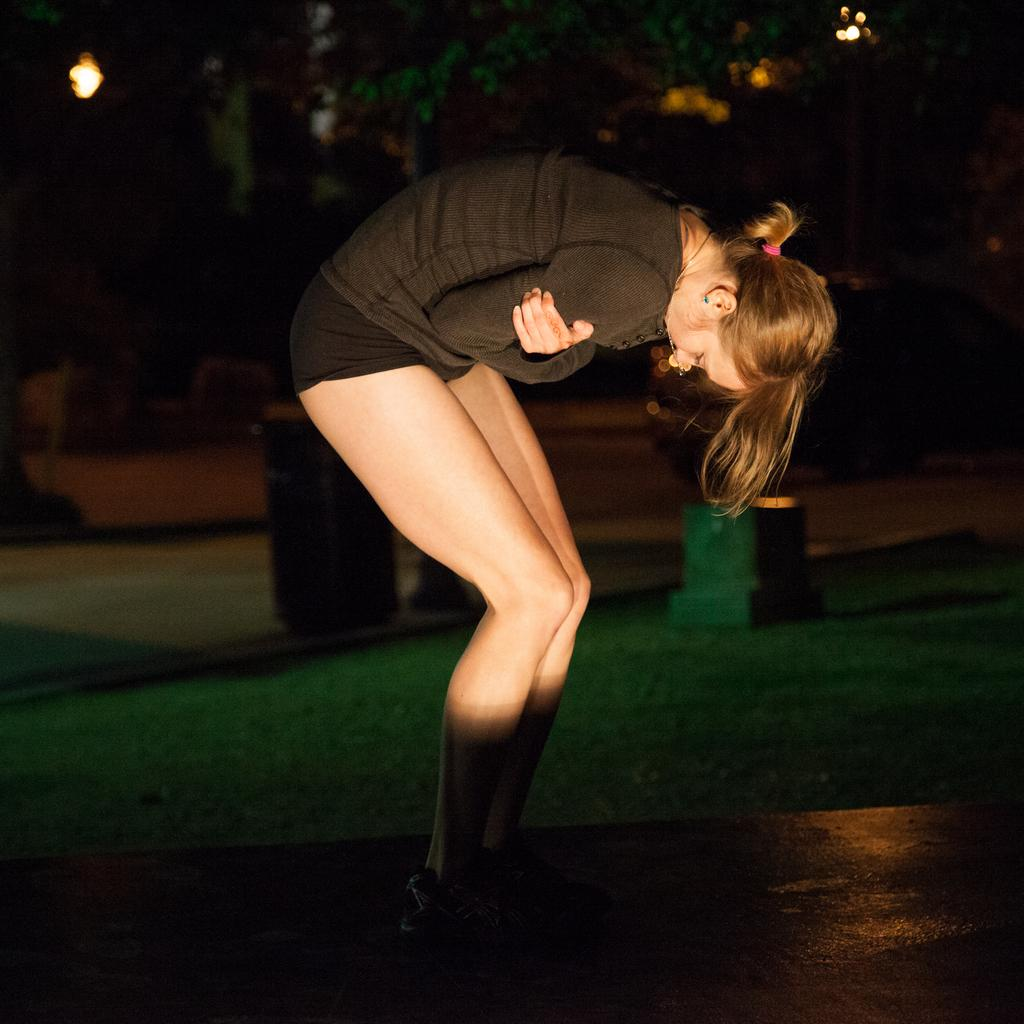Who is present in the image? There is a woman in the image. What is the woman's position in relation to the land? The woman is standing on the land. What color is the dress the woman is wearing? The woman is wearing a brown dress. What can be seen in the background of the image? There are trees in the background of the image. What type of flesh can be seen hanging from the trees in the image? There is no flesh hanging from the trees in the image; it only features a woman standing on the land and trees in the background. 